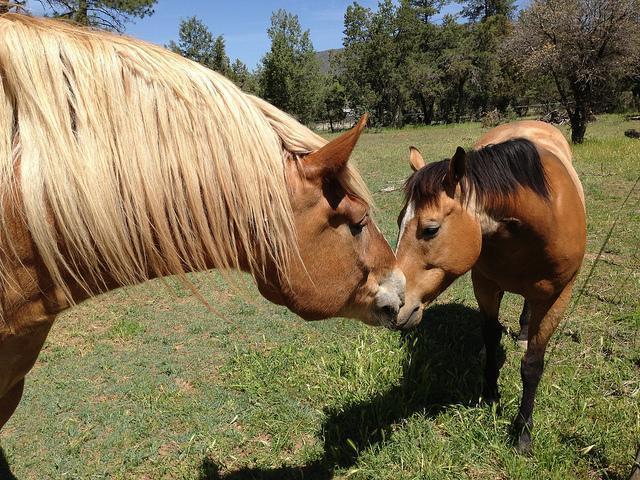How many animals can be seen?
Give a very brief answer. 2. How many horses are there?
Give a very brief answer. 2. How many toothbrushes are on the counter?
Give a very brief answer. 0. 